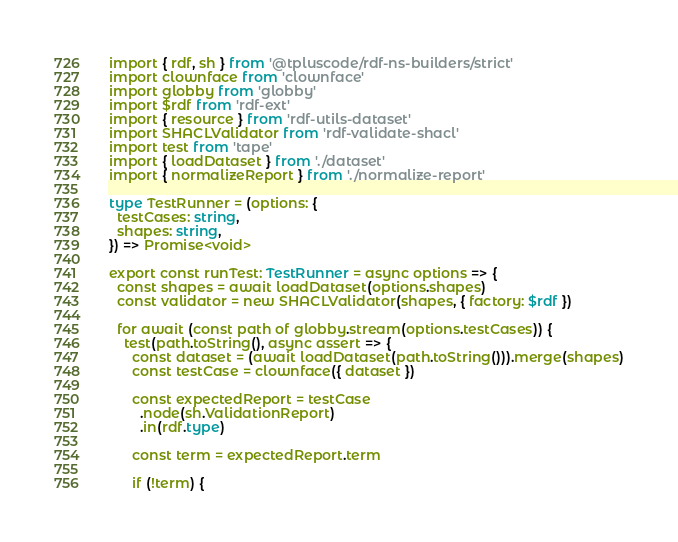<code> <loc_0><loc_0><loc_500><loc_500><_TypeScript_>import { rdf, sh } from '@tpluscode/rdf-ns-builders/strict'
import clownface from 'clownface'
import globby from 'globby'
import $rdf from 'rdf-ext'
import { resource } from 'rdf-utils-dataset'
import SHACLValidator from 'rdf-validate-shacl'
import test from 'tape'
import { loadDataset } from './dataset'
import { normalizeReport } from './normalize-report'

type TestRunner = (options: {
  testCases: string,
  shapes: string,
}) => Promise<void>

export const runTest: TestRunner = async options => {
  const shapes = await loadDataset(options.shapes)
  const validator = new SHACLValidator(shapes, { factory: $rdf })

  for await (const path of globby.stream(options.testCases)) {
    test(path.toString(), async assert => {
      const dataset = (await loadDataset(path.toString())).merge(shapes)
      const testCase = clownface({ dataset })

      const expectedReport = testCase
        .node(sh.ValidationReport)
        .in(rdf.type)

      const term = expectedReport.term

      if (!term) {</code> 